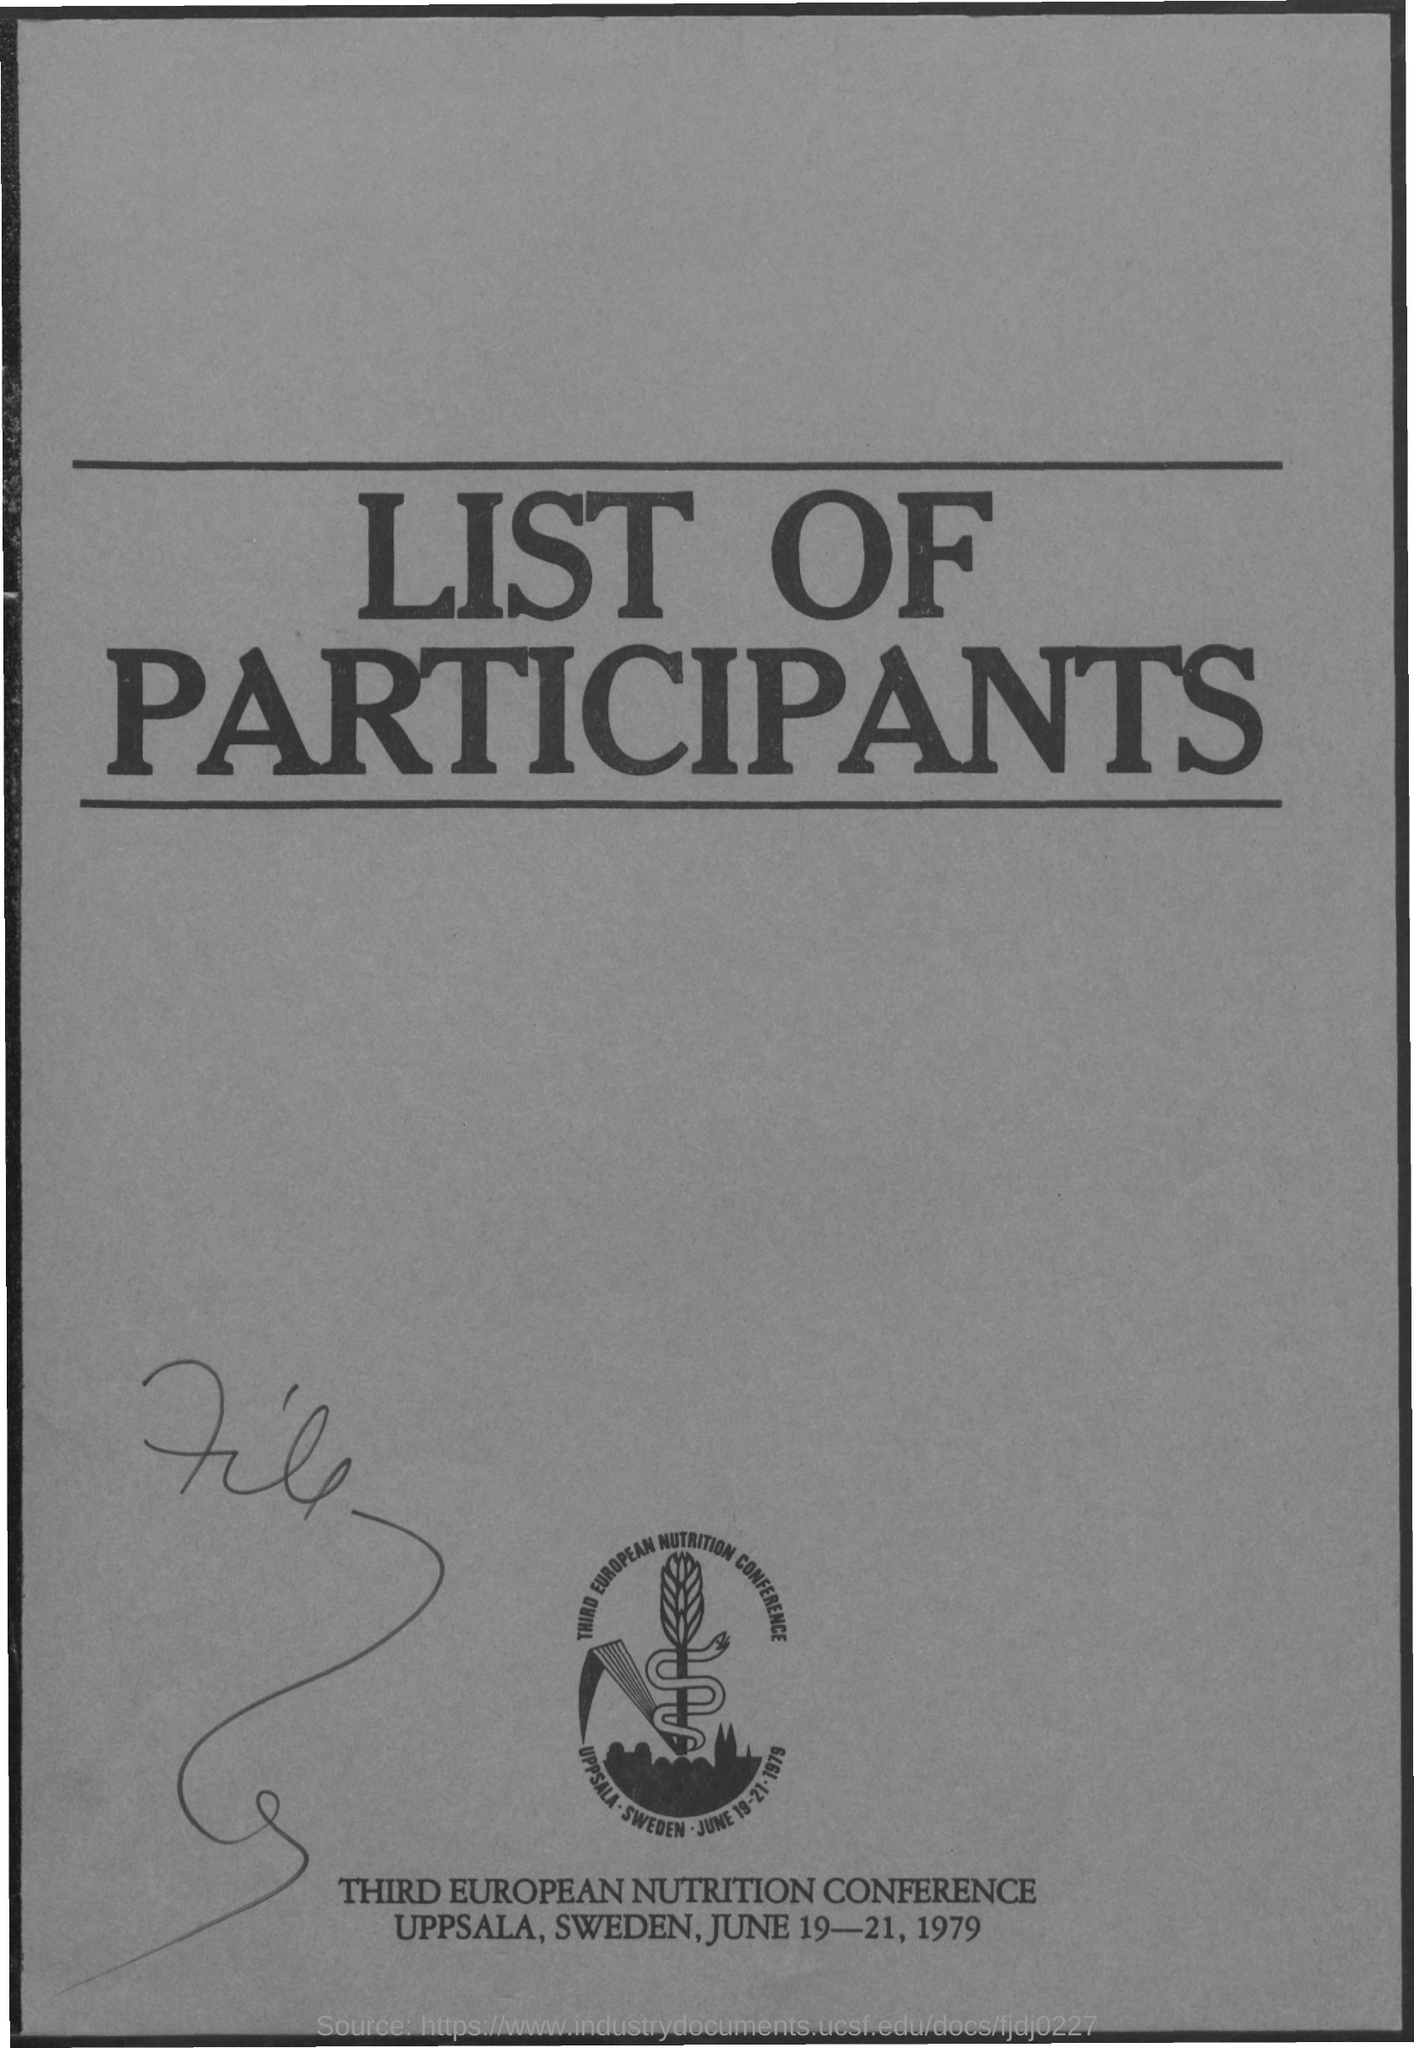Point out several critical features in this image. The conference was scheduled to take place on June 19-21, 1979. The Third European Nutrition Conference is named. 